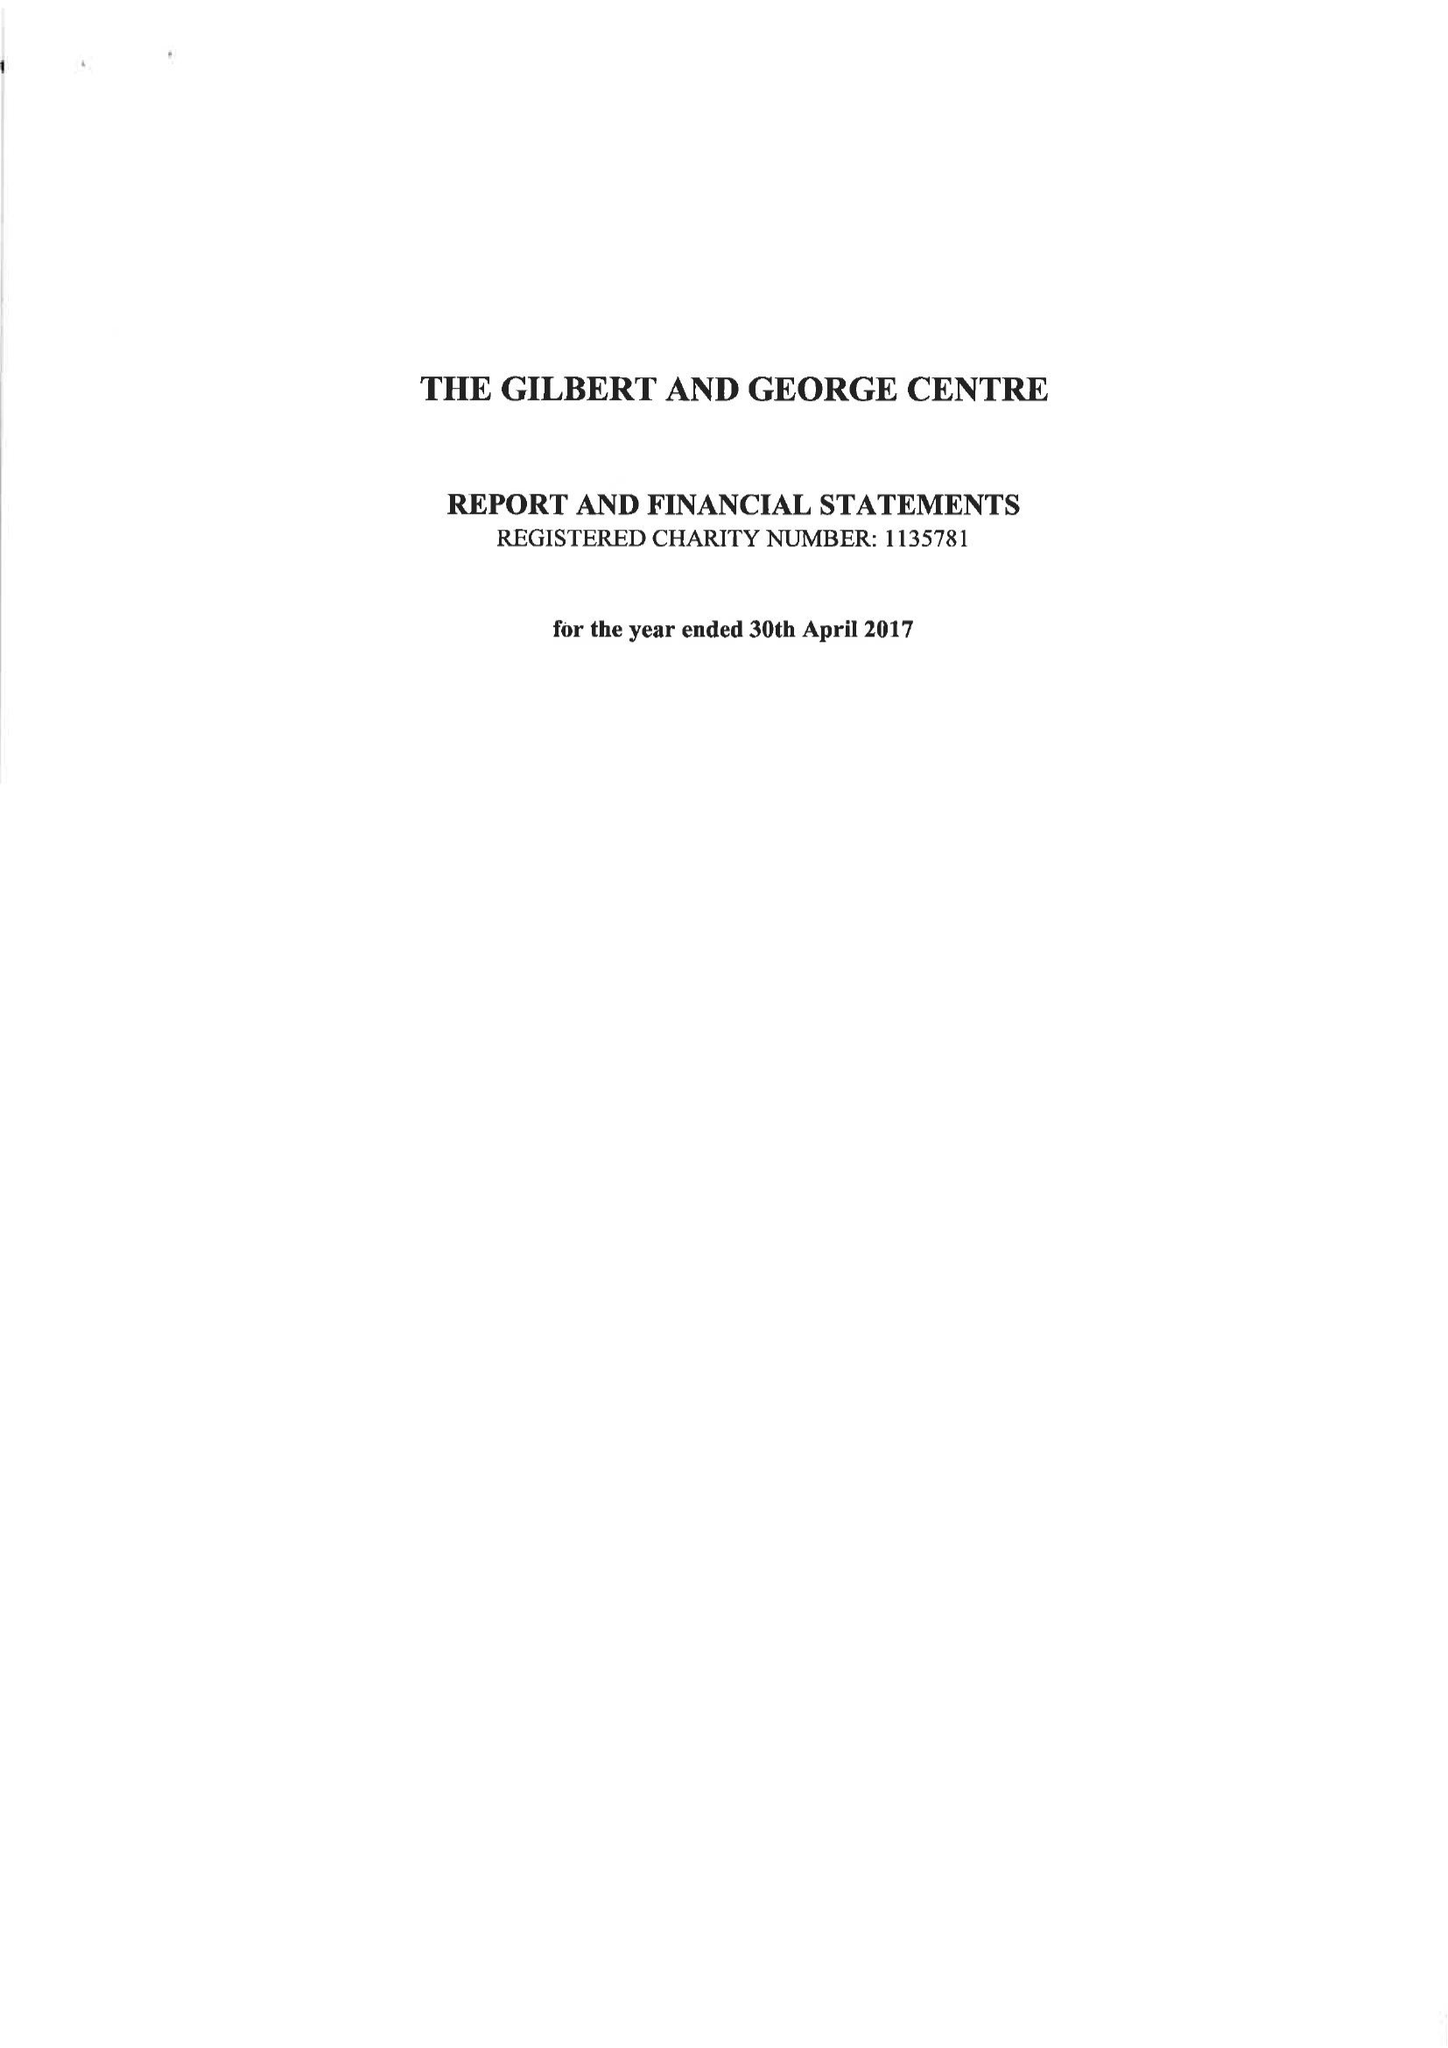What is the value for the address__postcode?
Answer the question using a single word or phrase. E1 6QE 